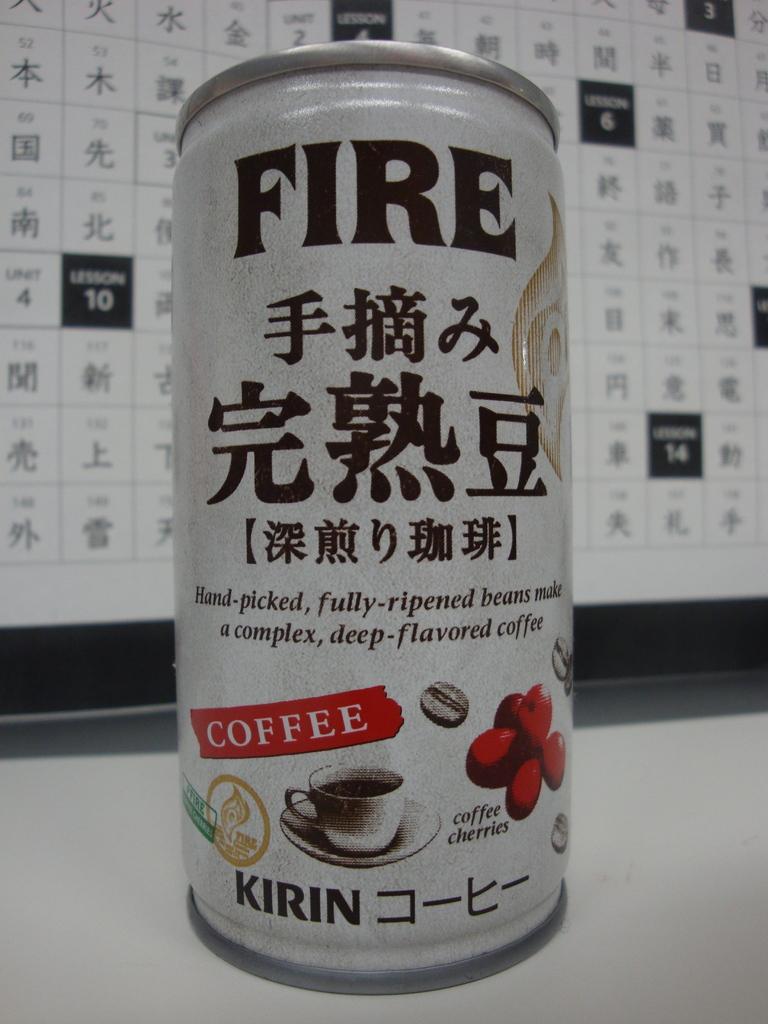Could you give a brief overview of what you see in this image? In this image, we can see a coke can and FIRE is printed in black color on it. 